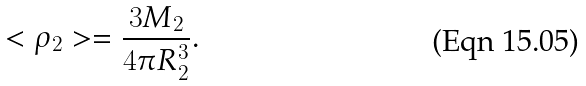Convert formula to latex. <formula><loc_0><loc_0><loc_500><loc_500>< \rho _ { 2 } > = \frac { 3 M _ { 2 } } { 4 \pi R _ { 2 } ^ { 3 } } .</formula> 